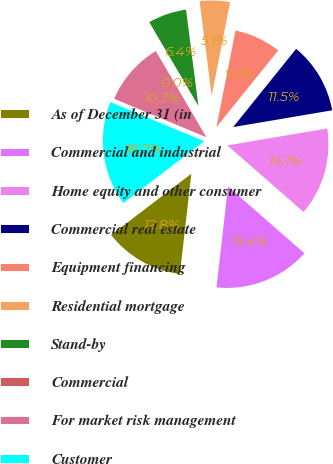<chart> <loc_0><loc_0><loc_500><loc_500><pie_chart><fcel>As of December 31 (in<fcel>Commercial and industrial<fcel>Home equity and other consumer<fcel>Commercial real estate<fcel>Equipment financing<fcel>Residential mortgage<fcel>Stand-by<fcel>Commercial<fcel>For market risk management<fcel>Customer<nl><fcel>12.82%<fcel>15.38%<fcel>14.1%<fcel>11.54%<fcel>7.69%<fcel>5.13%<fcel>6.41%<fcel>0.01%<fcel>10.26%<fcel>16.66%<nl></chart> 